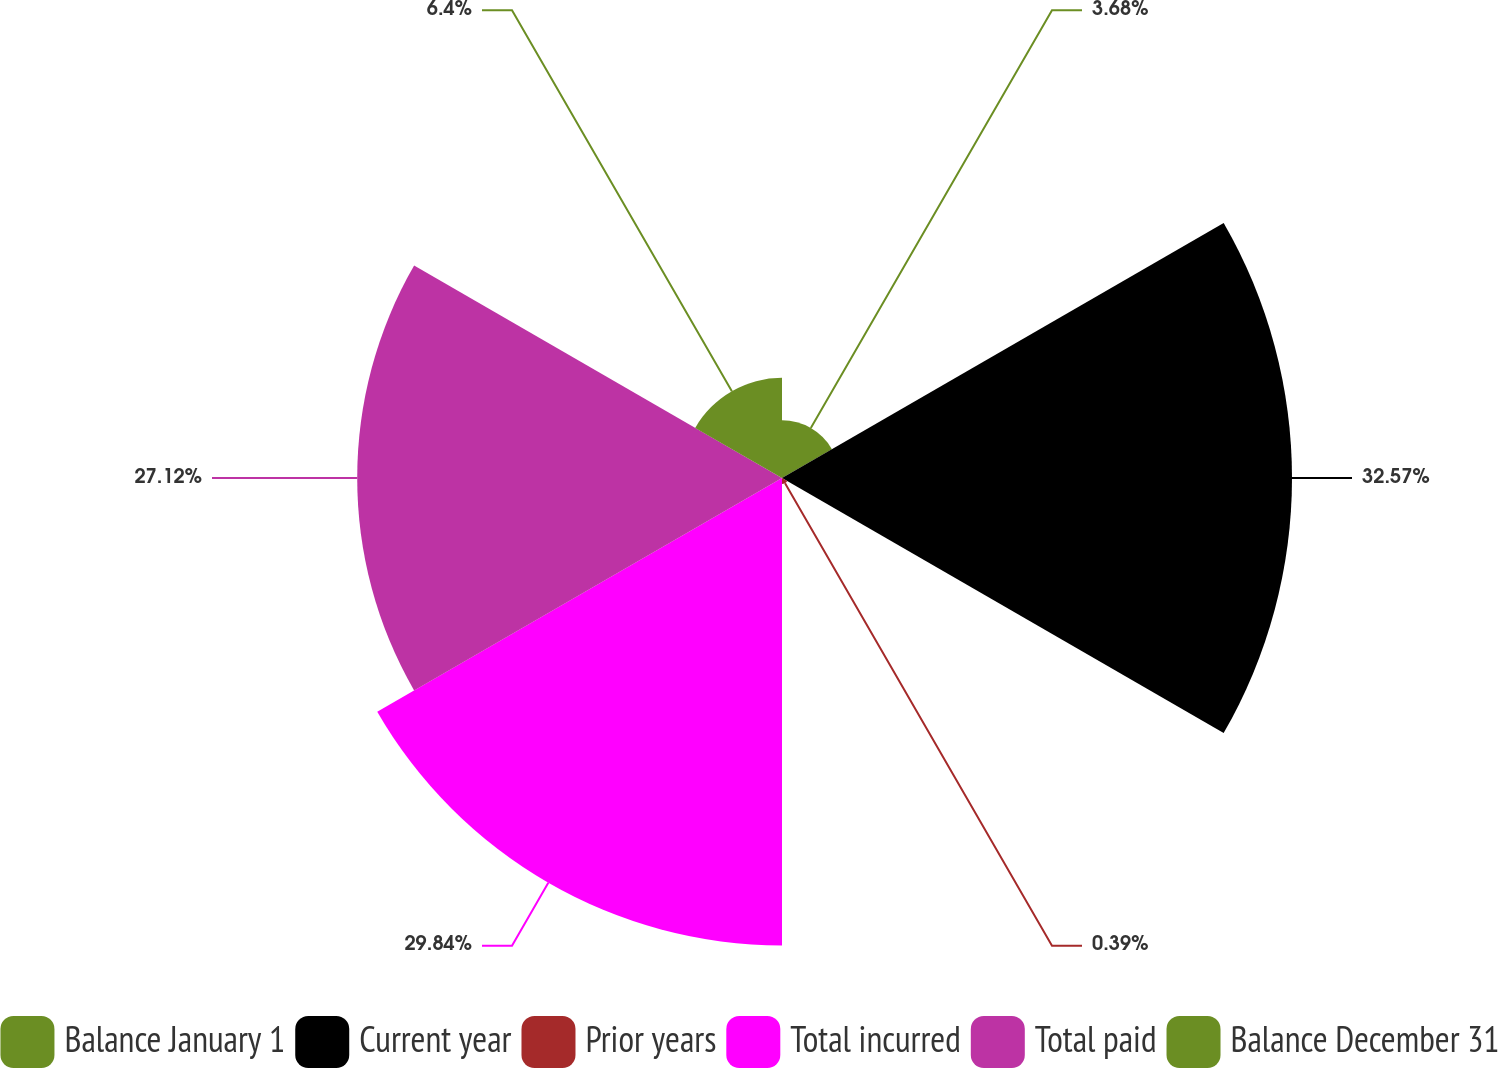<chart> <loc_0><loc_0><loc_500><loc_500><pie_chart><fcel>Balance January 1<fcel>Current year<fcel>Prior years<fcel>Total incurred<fcel>Total paid<fcel>Balance December 31<nl><fcel>3.68%<fcel>32.56%<fcel>0.39%<fcel>29.84%<fcel>27.12%<fcel>6.4%<nl></chart> 